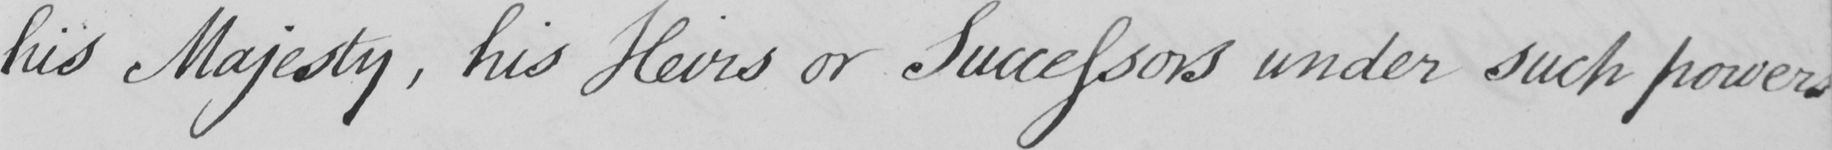What text is written in this handwritten line? his Majesty  , his Heirs or Successors under such powers 